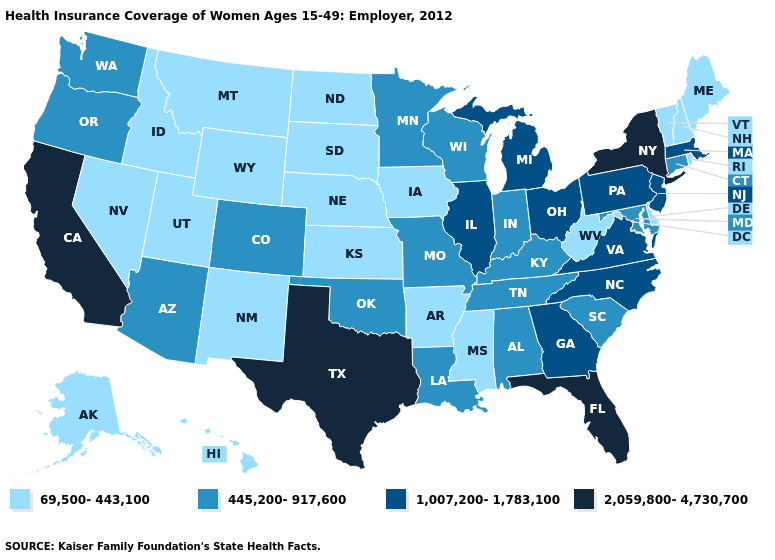Name the states that have a value in the range 1,007,200-1,783,100?
Quick response, please. Georgia, Illinois, Massachusetts, Michigan, New Jersey, North Carolina, Ohio, Pennsylvania, Virginia. Does the first symbol in the legend represent the smallest category?
Keep it brief. Yes. What is the value of Nevada?
Give a very brief answer. 69,500-443,100. Name the states that have a value in the range 2,059,800-4,730,700?
Keep it brief. California, Florida, New York, Texas. Does the first symbol in the legend represent the smallest category?
Quick response, please. Yes. Name the states that have a value in the range 1,007,200-1,783,100?
Write a very short answer. Georgia, Illinois, Massachusetts, Michigan, New Jersey, North Carolina, Ohio, Pennsylvania, Virginia. Is the legend a continuous bar?
Be succinct. No. Among the states that border Wyoming , which have the lowest value?
Short answer required. Idaho, Montana, Nebraska, South Dakota, Utah. Does West Virginia have the lowest value in the South?
Keep it brief. Yes. Among the states that border Ohio , does Michigan have the highest value?
Answer briefly. Yes. What is the value of Oregon?
Quick response, please. 445,200-917,600. What is the value of Minnesota?
Give a very brief answer. 445,200-917,600. What is the value of Massachusetts?
Keep it brief. 1,007,200-1,783,100. What is the value of South Dakota?
Be succinct. 69,500-443,100. 